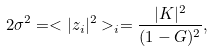Convert formula to latex. <formula><loc_0><loc_0><loc_500><loc_500>2 \sigma ^ { 2 } = < | z _ { i } | ^ { 2 } > _ { i } = \frac { | K | ^ { 2 } } { ( 1 - G ) ^ { 2 } } ,</formula> 